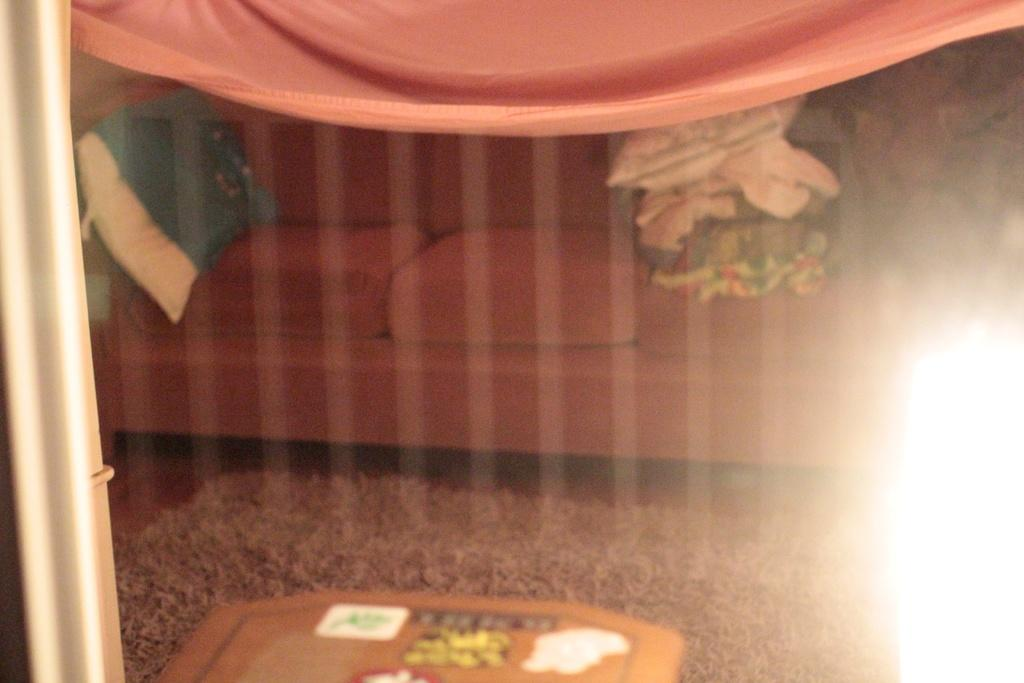What type of furniture is in the image? There is a sofa in the image. Where is the sofa located? The sofa is on the floor. What else can be seen on the floor in the image? There is a mat in the image. What is visible at the top of the image? There are cloths visible at the top of the image. What type of fork can be seen in the image? There is no fork present in the image. 